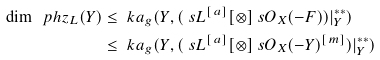<formula> <loc_0><loc_0><loc_500><loc_500>\dim \ p h z _ { L } ( Y ) & \leq \ k a _ { g } ( Y , ( \ s L ^ { [ \, a ] } [ \otimes ] \ s O _ { X } ( - F ) ) | _ { Y } ^ { * * } ) \\ & \leq \ k a _ { g } ( Y , ( \ s L ^ { [ \, a ] } [ \otimes ] \ s O _ { X } ( - Y ) ^ { [ \, m ] } ) | _ { Y } ^ { * * } )</formula> 